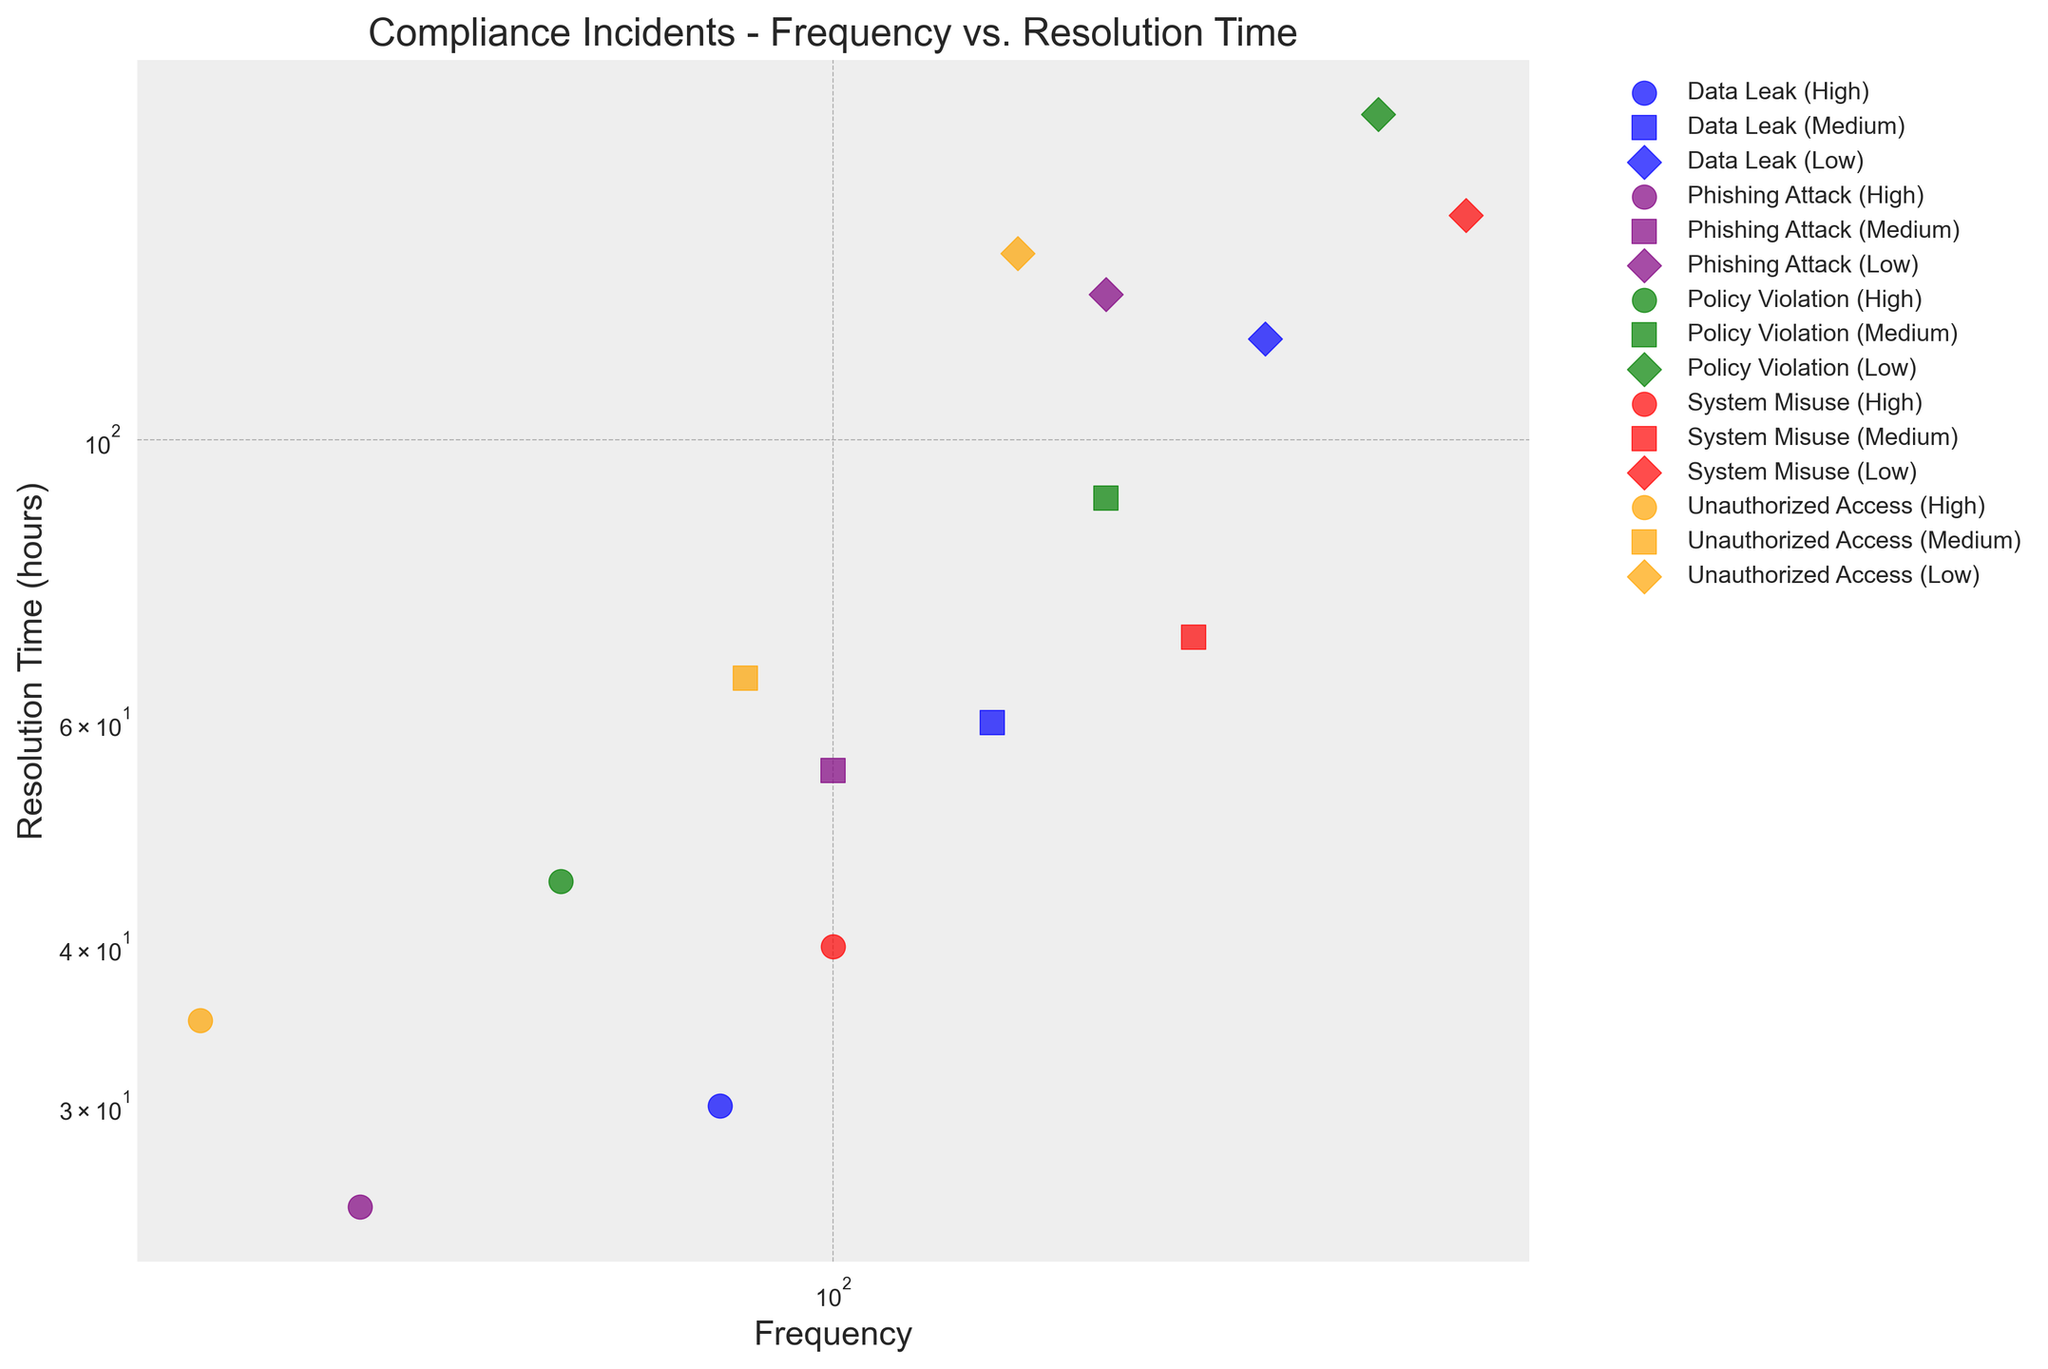What's the highest frequency of incidents for 'Low' severity across all types? To find the highest frequency for 'Low' severity, we look at the markers labeled as 'D'. The frequencies are 300 (Data Leak), 400 (Policy Violation), 500 (System Misuse), 200 (Phishing Attack), and 160 (Unauthorized Access). The highest among these is 500 for System Misuse.
Answer: 500 Which type and severity combination has the shortest resolution time? We need to identify the data point with the smallest 'Resolution Time' on the y-axis. The combination 'Phishing Attack (High)' has the shortest time, which is 25 hours.
Answer: Phishing Attack (High) Compare the frequency of 'System Misuse' incidents of 'Medium' severity with 'Policy Violation' incidents of 'Medium' severity. Which is higher? The markers for 'Medium' severity are 's'. The frequency for 'System Misuse (Medium)' is 250, and for 'Policy Violation (Medium)' is 200. Therefore, 'System Misuse (Medium)' has a higher frequency.
Answer: System Misuse (Medium) What is the approximate difference in resolution time between 'High' and 'Low' severity for 'Data Leak' incidents? For 'Data Leak', the 'High' severity has a resolution time of 30 hours and the 'Low' severity has a resolution time of 120 hours. The difference is 120 - 30 = 90 hours.
Answer: 90 hours Among 'High' severity incidents, which type has the lowest frequency and what is that frequency? For 'High' severity, we look at the markers labeled 'o'. The lowest frequency is for 'Unauthorized Access (High)', which is 20.
Answer: Unauthorized Access, 20 How does the resolution time for 'Medium' severity 'Phishing Attack' incidents compare to 'Medium' severity 'Unauthorized Access' incidents? 'Medium' severity markers are 's'. The resolution time for 'Phishing Attack (Medium)' is 55 hours, while for 'Unauthorized Access (Medium)' it is 65 hours. Therefore, 'Phishing Attack (Medium)' has a shorter resolution time.
Answer: Phishing Attack (Medium) Calculate the average resolution time of 'High' severity incidents across all types. 'High' severity markers are 'o'. The resolution times are 30 (Data Leak), 45 (Policy Violation), 40 (System Misuse), 25 (Phishing Attack), and 35 (Unauthorized Access). The average is (30 + 45 + 40 + 25 + 35) / 5 = 35 hours.
Answer: 35 hours Which type of 'Low' severity incident has the longest resolution time, and what is that time? For 'Low' severity, markers are 'D'. The resolution times are 120 (Data Leak), 180 (Policy Violation), 150 (System Misuse), 130 (Phishing Attack), and 140 (Unauthorized Access). The longest resolution time is 180 for 'Policy Violation'.
Answer: Policy Violation, 180 